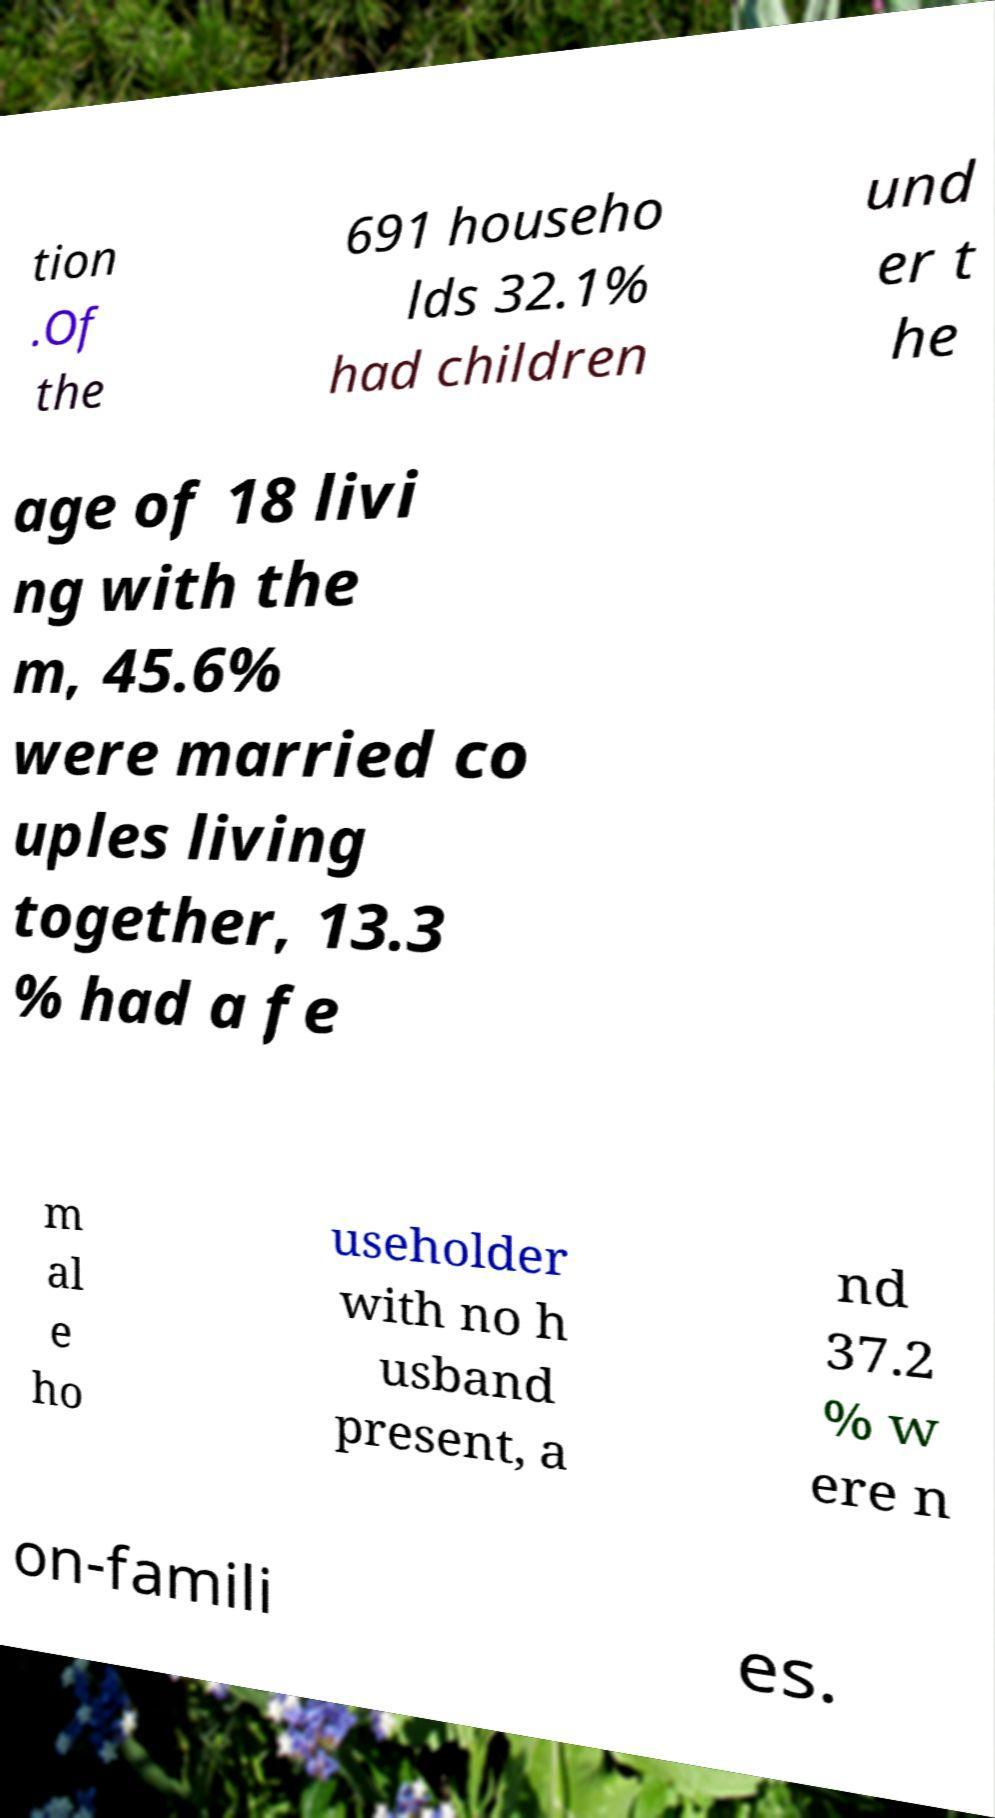There's text embedded in this image that I need extracted. Can you transcribe it verbatim? tion .Of the 691 househo lds 32.1% had children und er t he age of 18 livi ng with the m, 45.6% were married co uples living together, 13.3 % had a fe m al e ho useholder with no h usband present, a nd 37.2 % w ere n on-famili es. 